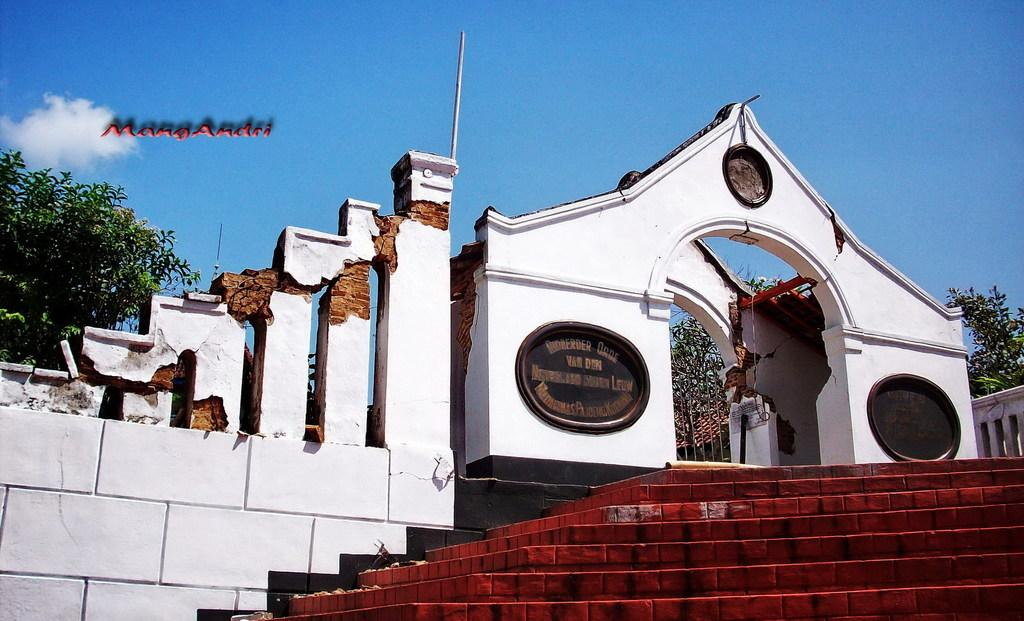What is the main subject of the picture? The main subject of the picture is a collapsed building. What can be seen in the vicinity of the collapsed building? There are stairs visible in the picture. What type of vegetation is present in the picture? There are trees in the picture. What type of form can be seen hanging from the trees in the image? There is no form hanging from the trees in the image; only the collapsed building, stairs, and trees are present. Can you tell me how many turkeys are visible in the image? There are no turkeys visible in the image; it features a collapsed building, stairs, and trees. 